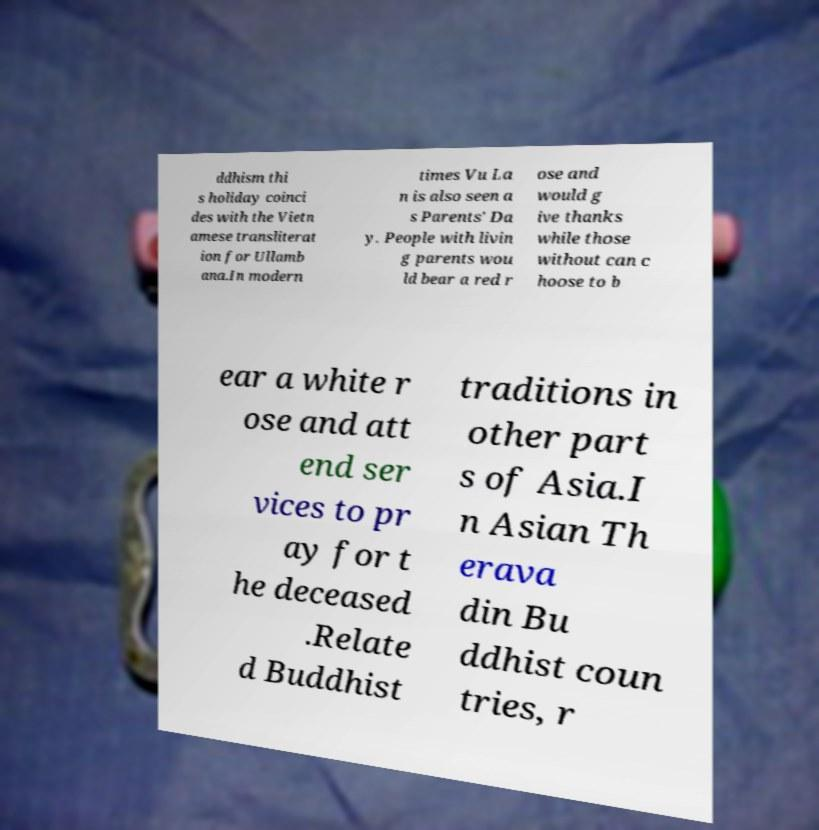Could you extract and type out the text from this image? ddhism thi s holiday coinci des with the Vietn amese transliterat ion for Ullamb ana.In modern times Vu La n is also seen a s Parents' Da y. People with livin g parents wou ld bear a red r ose and would g ive thanks while those without can c hoose to b ear a white r ose and att end ser vices to pr ay for t he deceased .Relate d Buddhist traditions in other part s of Asia.I n Asian Th erava din Bu ddhist coun tries, r 